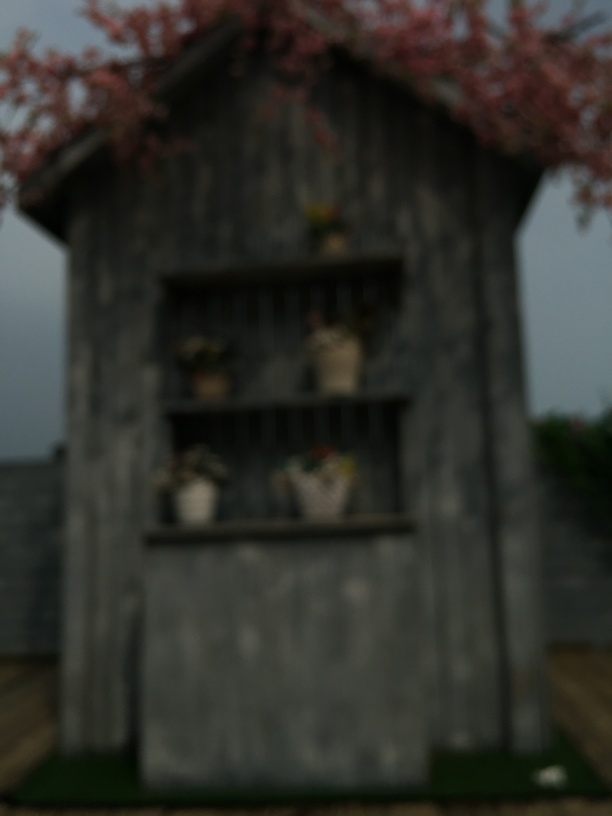What weather or time of day does the image suggest? Due to the overcast sky and dull lighting, it suggests either an early morning before the sun fully rises or an overcast day that would result in such diffused light. 